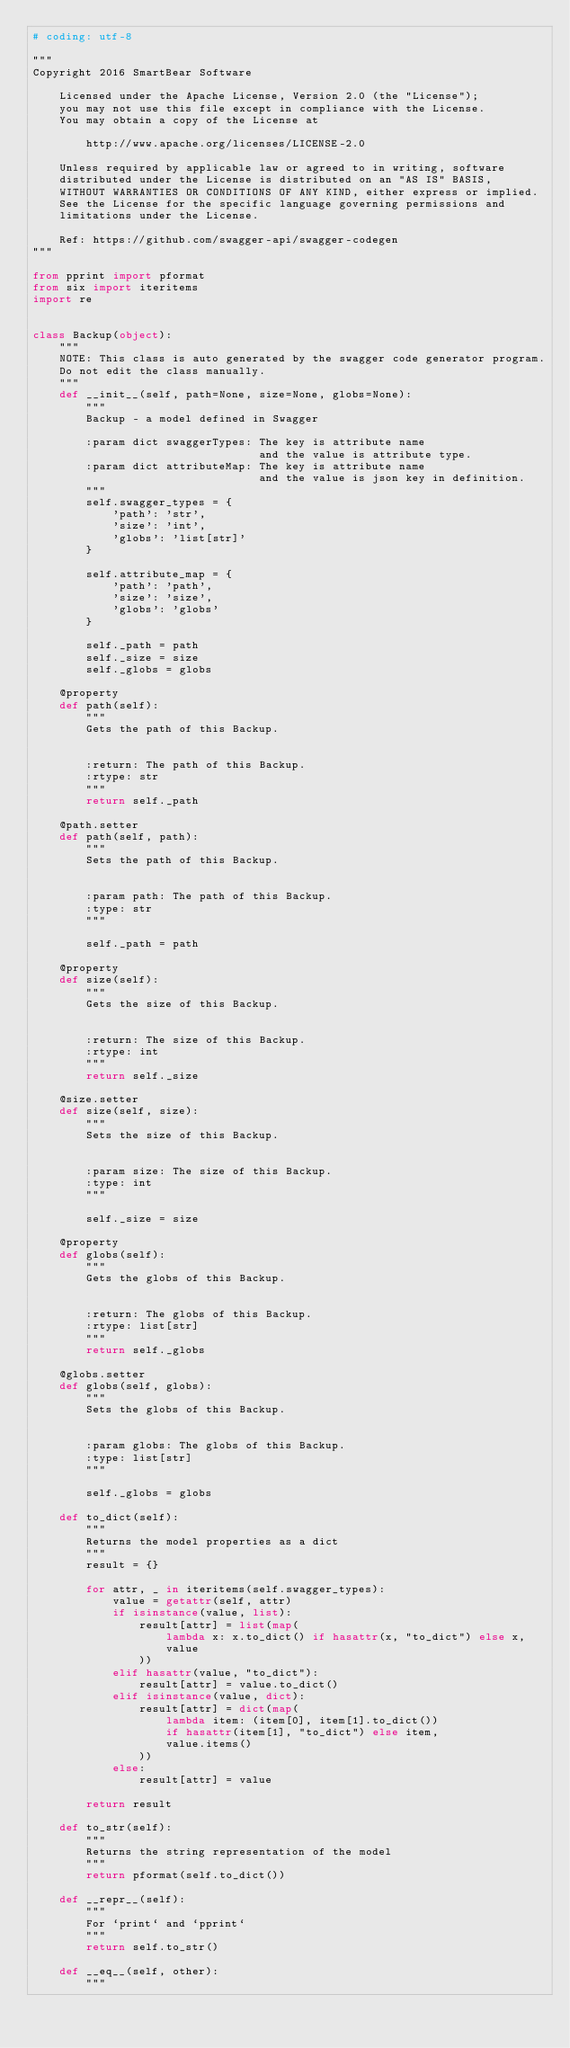Convert code to text. <code><loc_0><loc_0><loc_500><loc_500><_Python_># coding: utf-8

"""
Copyright 2016 SmartBear Software

    Licensed under the Apache License, Version 2.0 (the "License");
    you may not use this file except in compliance with the License.
    You may obtain a copy of the License at

        http://www.apache.org/licenses/LICENSE-2.0

    Unless required by applicable law or agreed to in writing, software
    distributed under the License is distributed on an "AS IS" BASIS,
    WITHOUT WARRANTIES OR CONDITIONS OF ANY KIND, either express or implied.
    See the License for the specific language governing permissions and
    limitations under the License.

    Ref: https://github.com/swagger-api/swagger-codegen
"""

from pprint import pformat
from six import iteritems
import re


class Backup(object):
    """
    NOTE: This class is auto generated by the swagger code generator program.
    Do not edit the class manually.
    """
    def __init__(self, path=None, size=None, globs=None):
        """
        Backup - a model defined in Swagger

        :param dict swaggerTypes: The key is attribute name
                                  and the value is attribute type.
        :param dict attributeMap: The key is attribute name
                                  and the value is json key in definition.
        """
        self.swagger_types = {
            'path': 'str',
            'size': 'int',
            'globs': 'list[str]'
        }

        self.attribute_map = {
            'path': 'path',
            'size': 'size',
            'globs': 'globs'
        }

        self._path = path
        self._size = size
        self._globs = globs

    @property
    def path(self):
        """
        Gets the path of this Backup.


        :return: The path of this Backup.
        :rtype: str
        """
        return self._path

    @path.setter
    def path(self, path):
        """
        Sets the path of this Backup.


        :param path: The path of this Backup.
        :type: str
        """
        
        self._path = path

    @property
    def size(self):
        """
        Gets the size of this Backup.


        :return: The size of this Backup.
        :rtype: int
        """
        return self._size

    @size.setter
    def size(self, size):
        """
        Sets the size of this Backup.


        :param size: The size of this Backup.
        :type: int
        """
        
        self._size = size

    @property
    def globs(self):
        """
        Gets the globs of this Backup.


        :return: The globs of this Backup.
        :rtype: list[str]
        """
        return self._globs

    @globs.setter
    def globs(self, globs):
        """
        Sets the globs of this Backup.


        :param globs: The globs of this Backup.
        :type: list[str]
        """
        
        self._globs = globs

    def to_dict(self):
        """
        Returns the model properties as a dict
        """
        result = {}

        for attr, _ in iteritems(self.swagger_types):
            value = getattr(self, attr)
            if isinstance(value, list):
                result[attr] = list(map(
                    lambda x: x.to_dict() if hasattr(x, "to_dict") else x,
                    value
                ))
            elif hasattr(value, "to_dict"):
                result[attr] = value.to_dict()
            elif isinstance(value, dict):
                result[attr] = dict(map(
                    lambda item: (item[0], item[1].to_dict())
                    if hasattr(item[1], "to_dict") else item,
                    value.items()
                ))
            else:
                result[attr] = value

        return result

    def to_str(self):
        """
        Returns the string representation of the model
        """
        return pformat(self.to_dict())

    def __repr__(self):
        """
        For `print` and `pprint`
        """
        return self.to_str()

    def __eq__(self, other):
        """</code> 